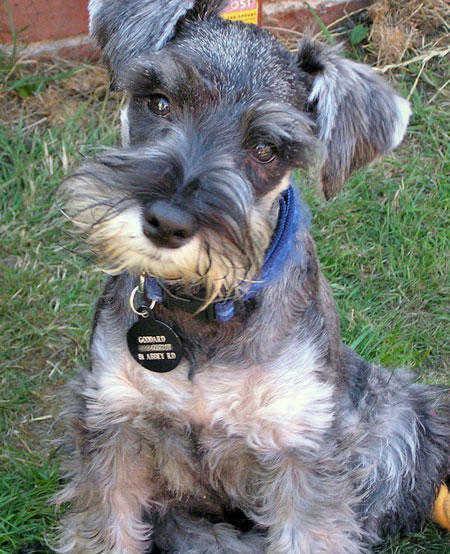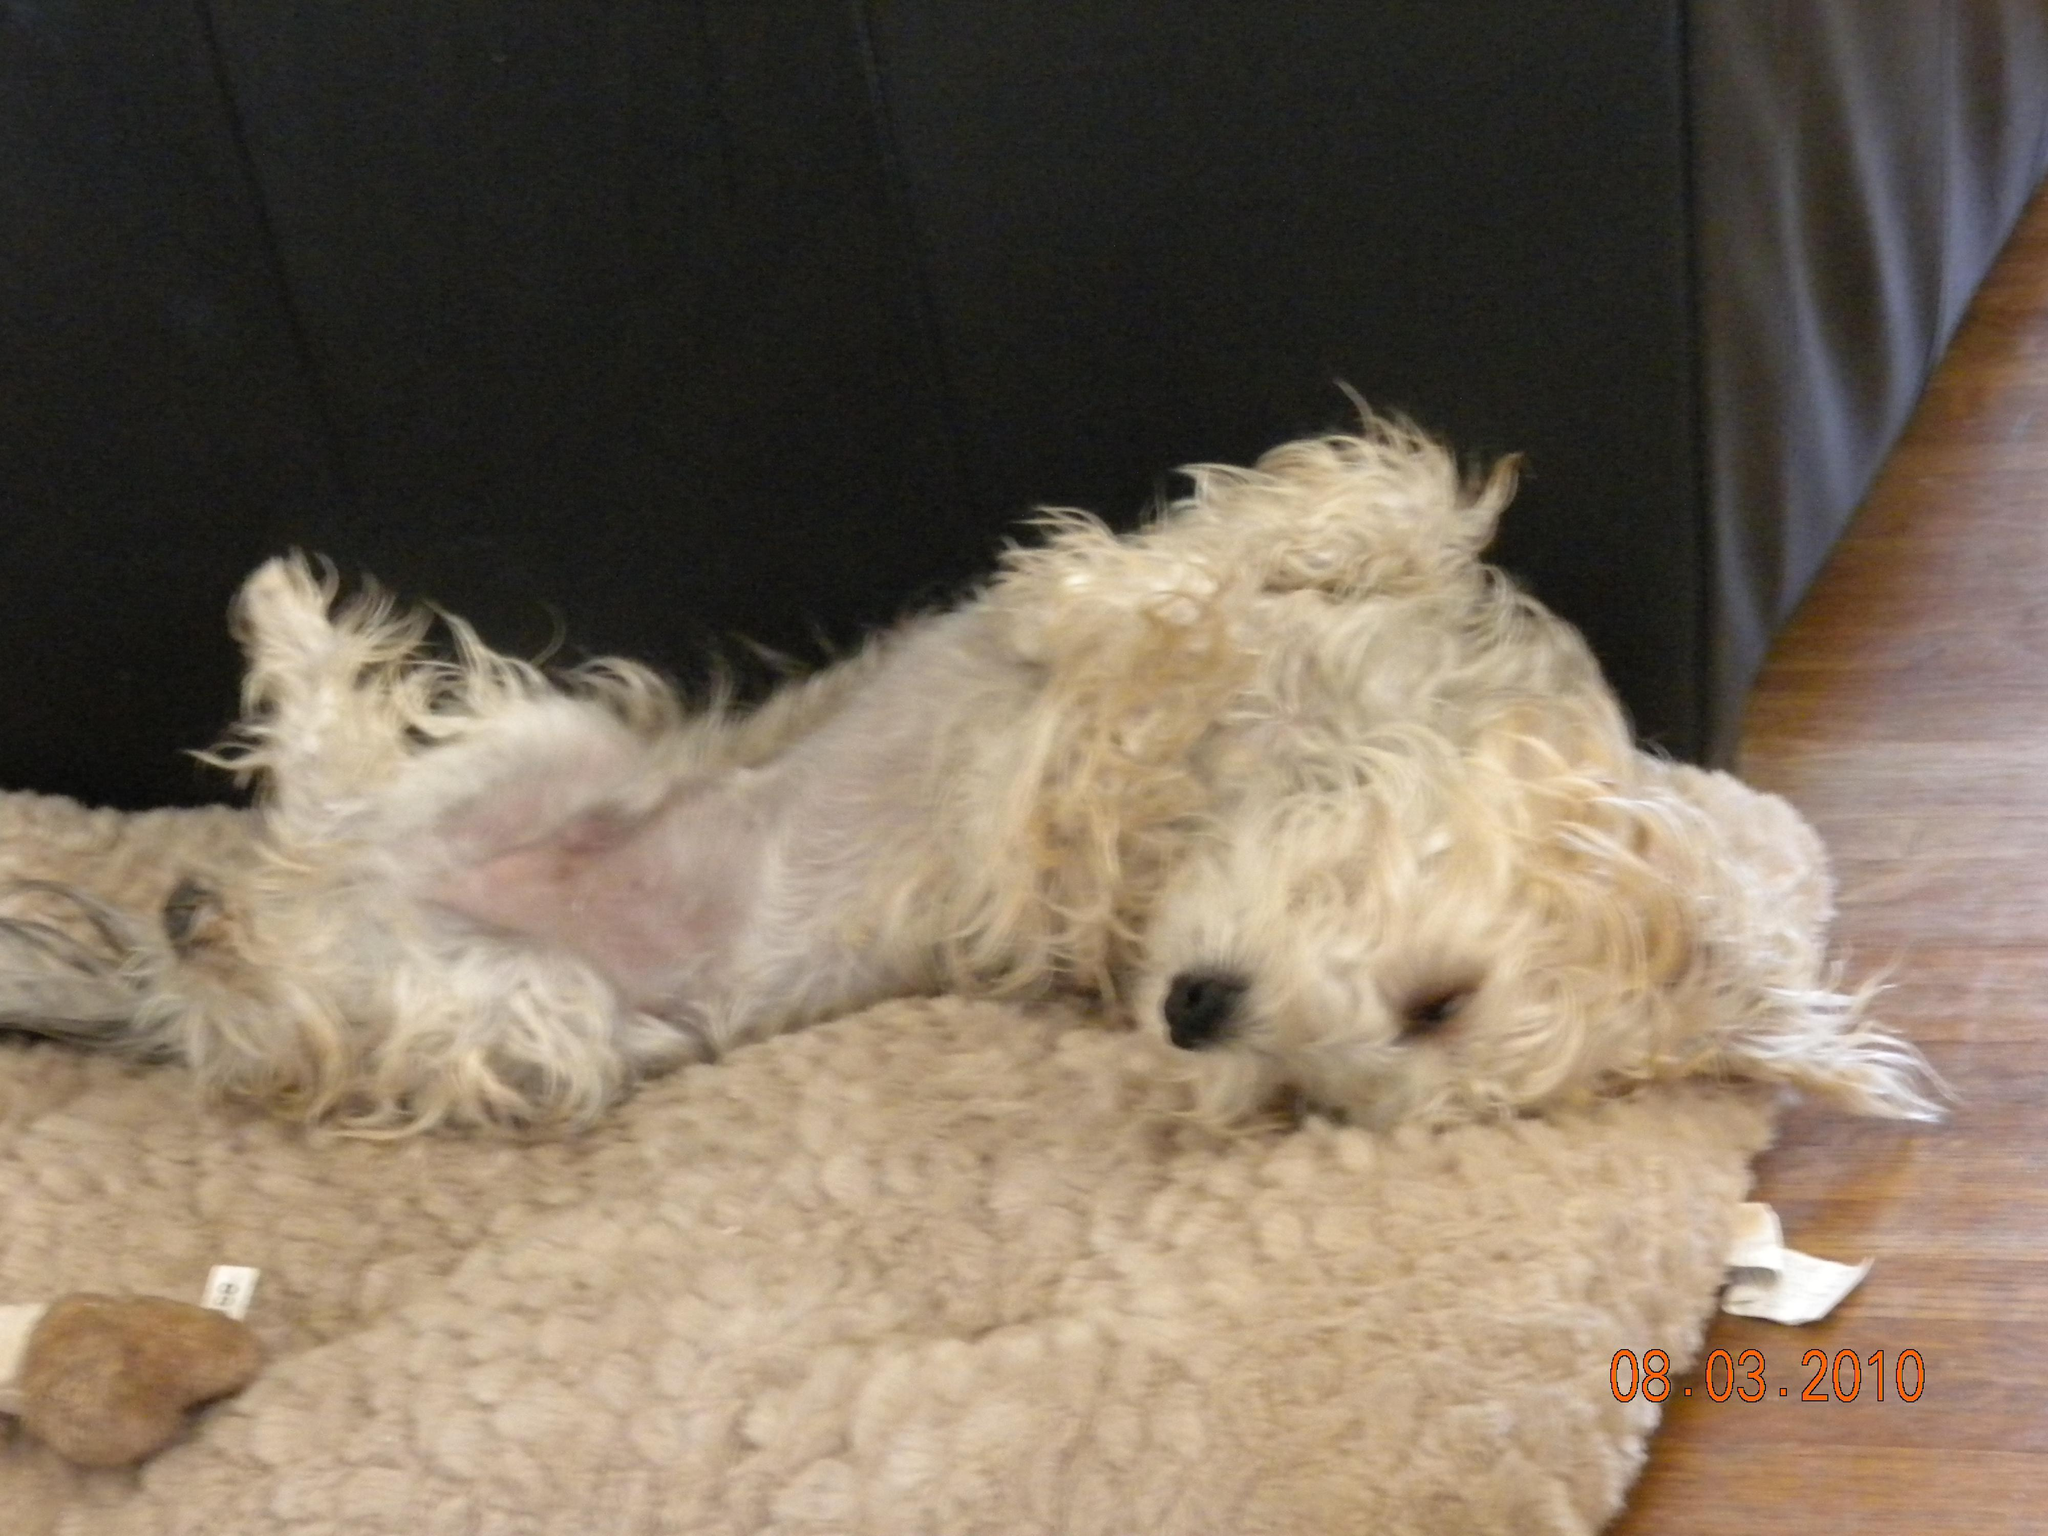The first image is the image on the left, the second image is the image on the right. Analyze the images presented: Is the assertion "There is an all white dog laying down." valid? Answer yes or no. Yes. The first image is the image on the left, the second image is the image on the right. Evaluate the accuracy of this statement regarding the images: "A dog is sitting in one picture and in the other picture ta dog is lying down and asleep.". Is it true? Answer yes or no. Yes. 